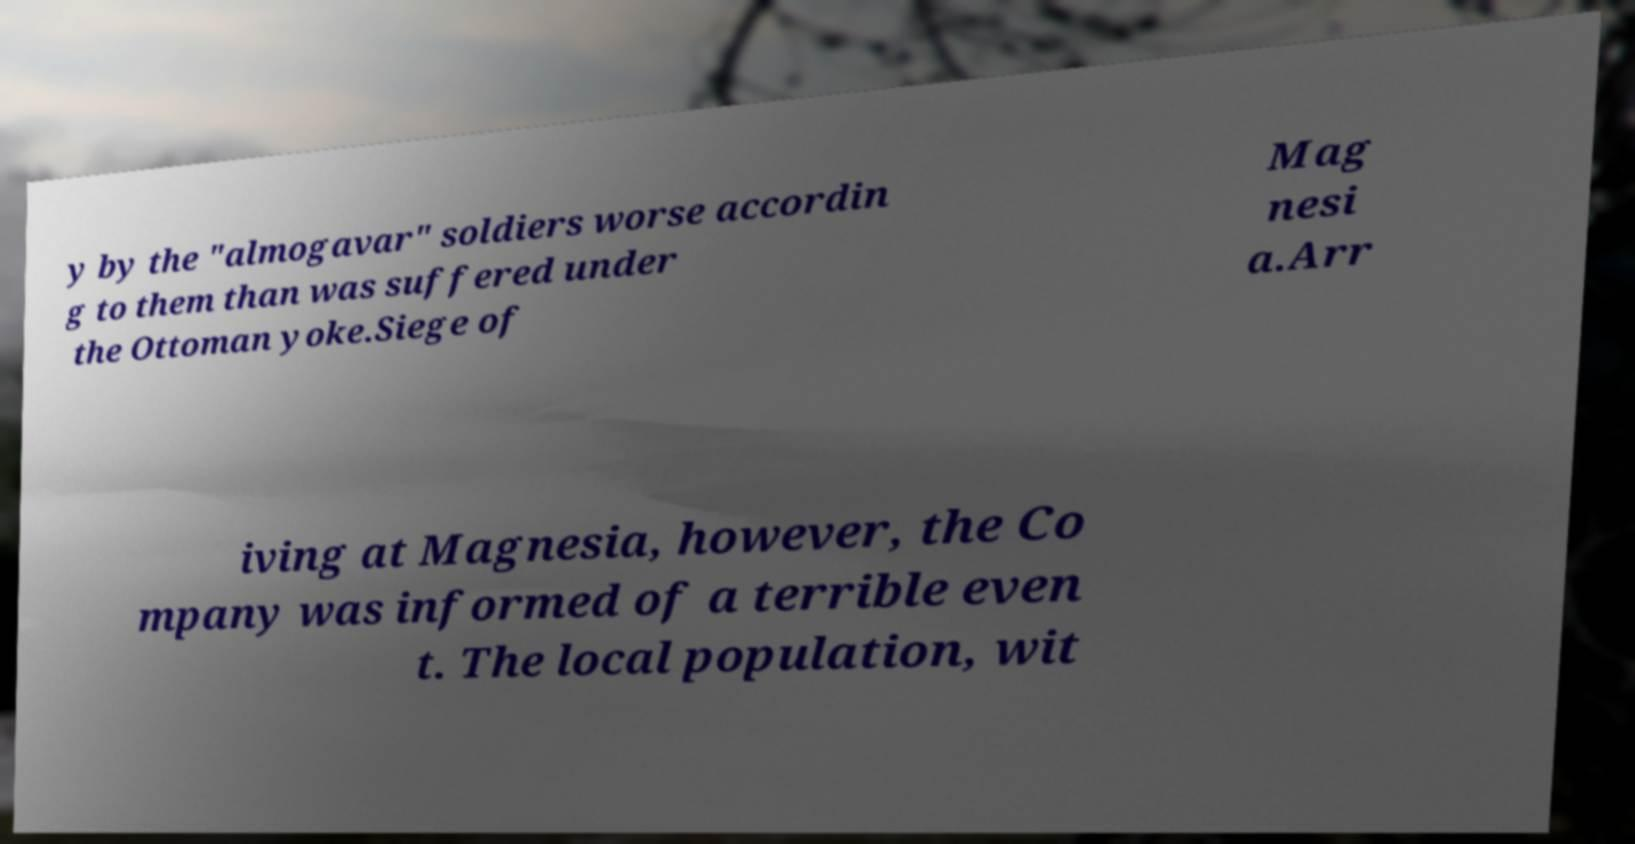There's text embedded in this image that I need extracted. Can you transcribe it verbatim? y by the "almogavar" soldiers worse accordin g to them than was suffered under the Ottoman yoke.Siege of Mag nesi a.Arr iving at Magnesia, however, the Co mpany was informed of a terrible even t. The local population, wit 